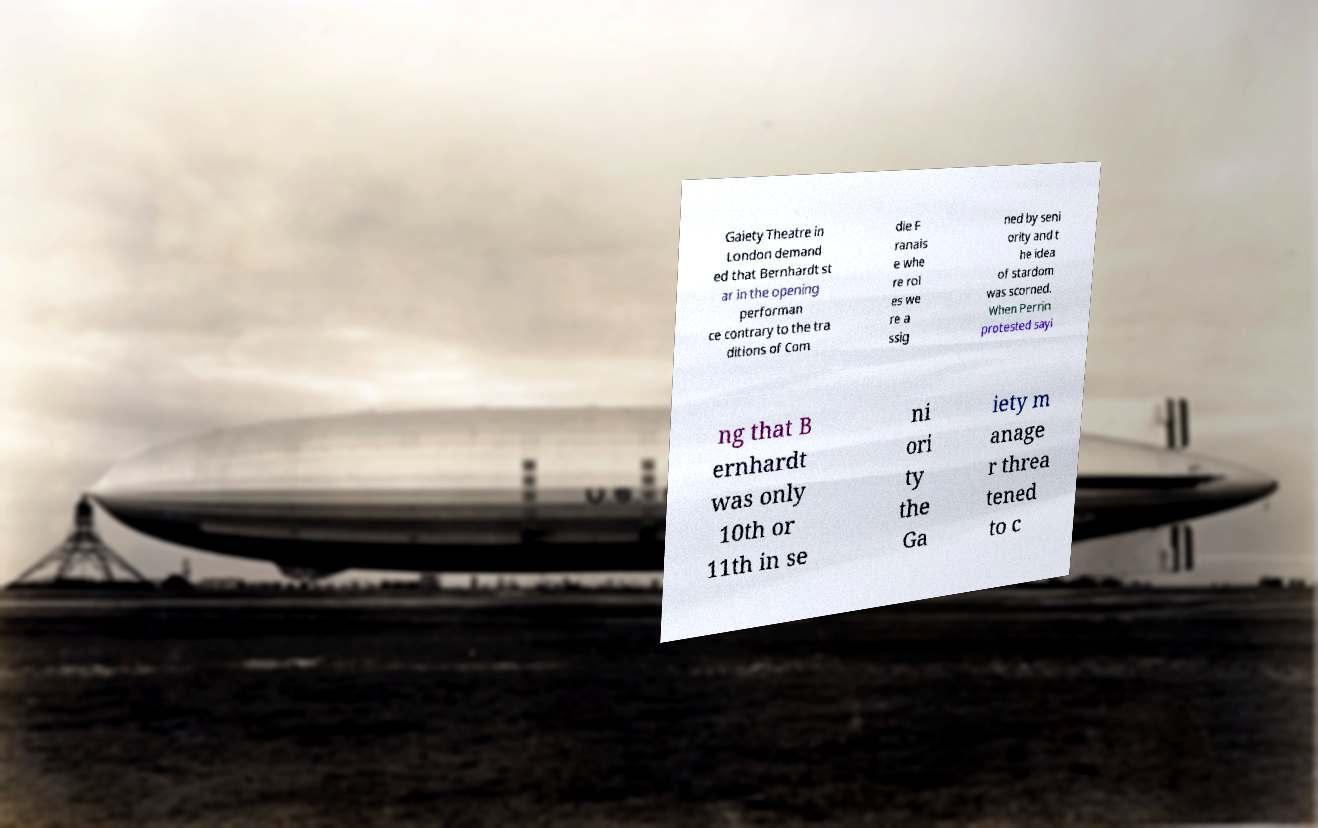I need the written content from this picture converted into text. Can you do that? Gaiety Theatre in London demand ed that Bernhardt st ar in the opening performan ce contrary to the tra ditions of Com die F ranais e whe re rol es we re a ssig ned by seni ority and t he idea of stardom was scorned. When Perrin protested sayi ng that B ernhardt was only 10th or 11th in se ni ori ty the Ga iety m anage r threa tened to c 